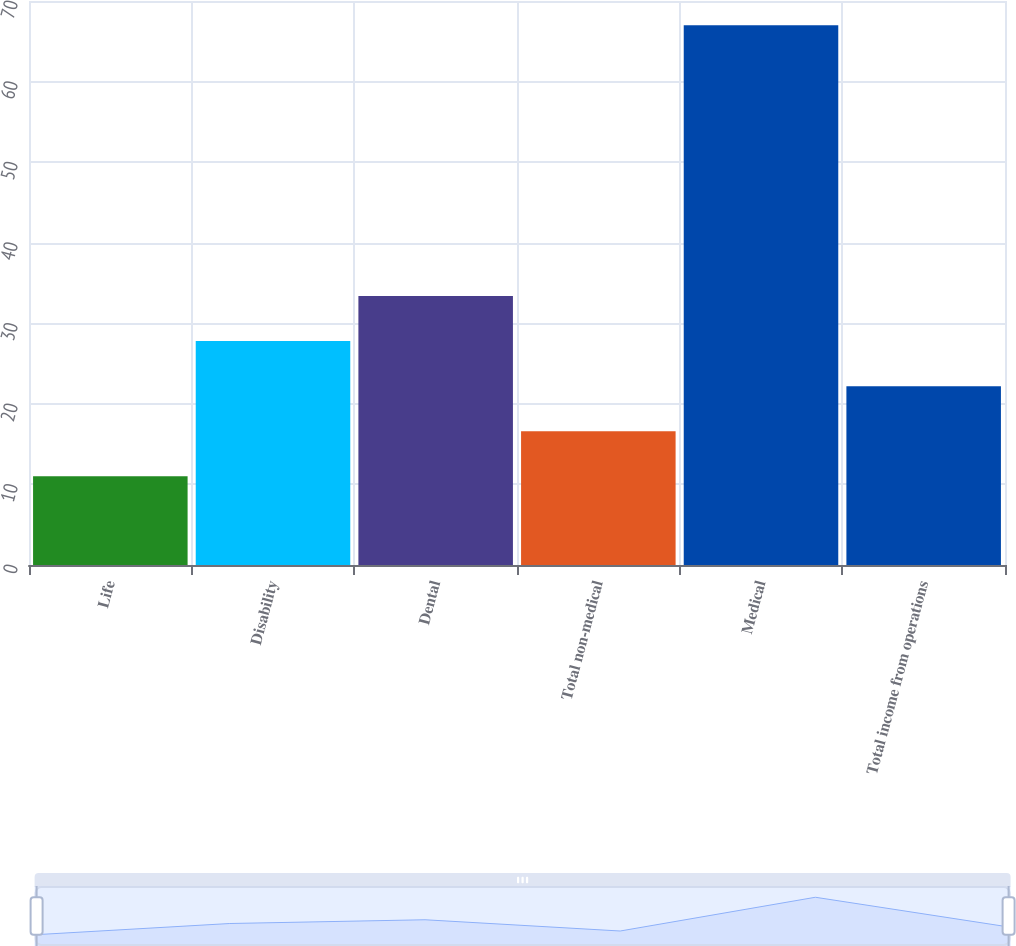Convert chart. <chart><loc_0><loc_0><loc_500><loc_500><bar_chart><fcel>Life<fcel>Disability<fcel>Dental<fcel>Total non-medical<fcel>Medical<fcel>Total income from operations<nl><fcel>11<fcel>27.8<fcel>33.4<fcel>16.6<fcel>67<fcel>22.2<nl></chart> 